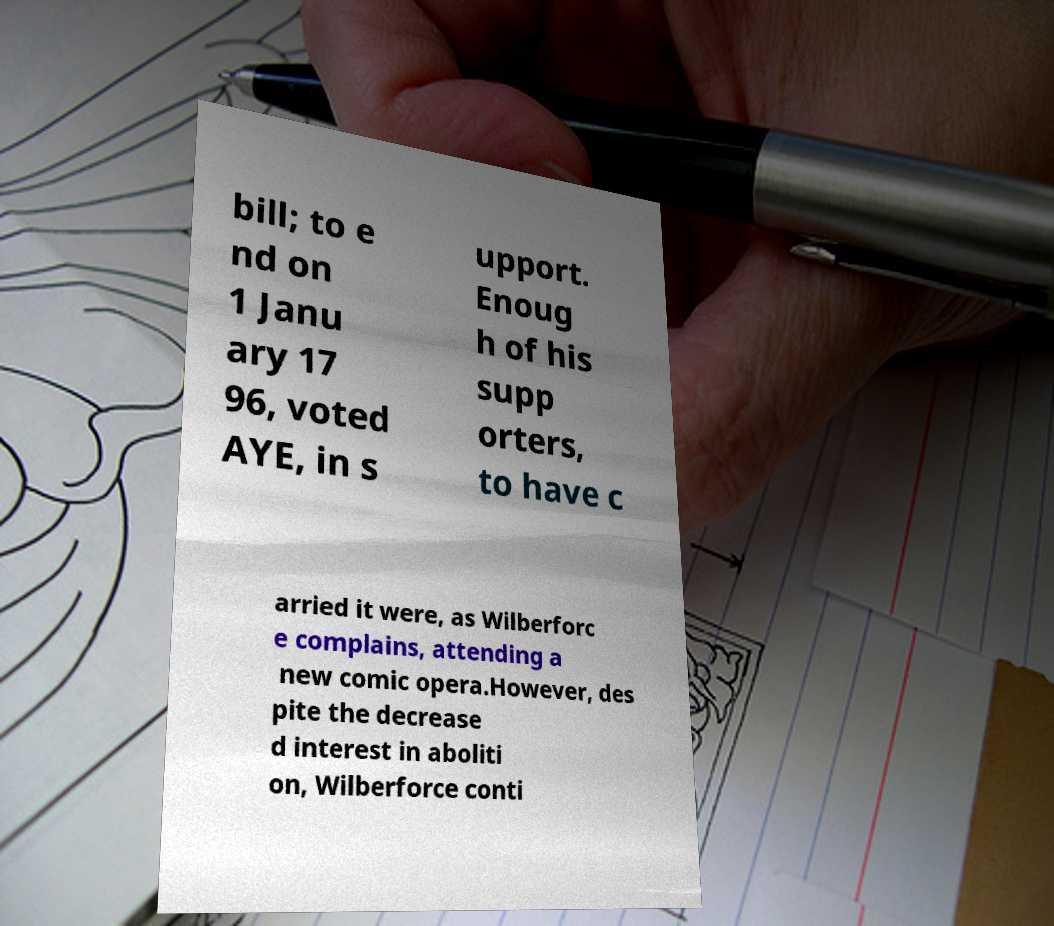Please read and relay the text visible in this image. What does it say? bill; to e nd on 1 Janu ary 17 96, voted AYE, in s upport. Enoug h of his supp orters, to have c arried it were, as Wilberforc e complains, attending a new comic opera.However, des pite the decrease d interest in aboliti on, Wilberforce conti 